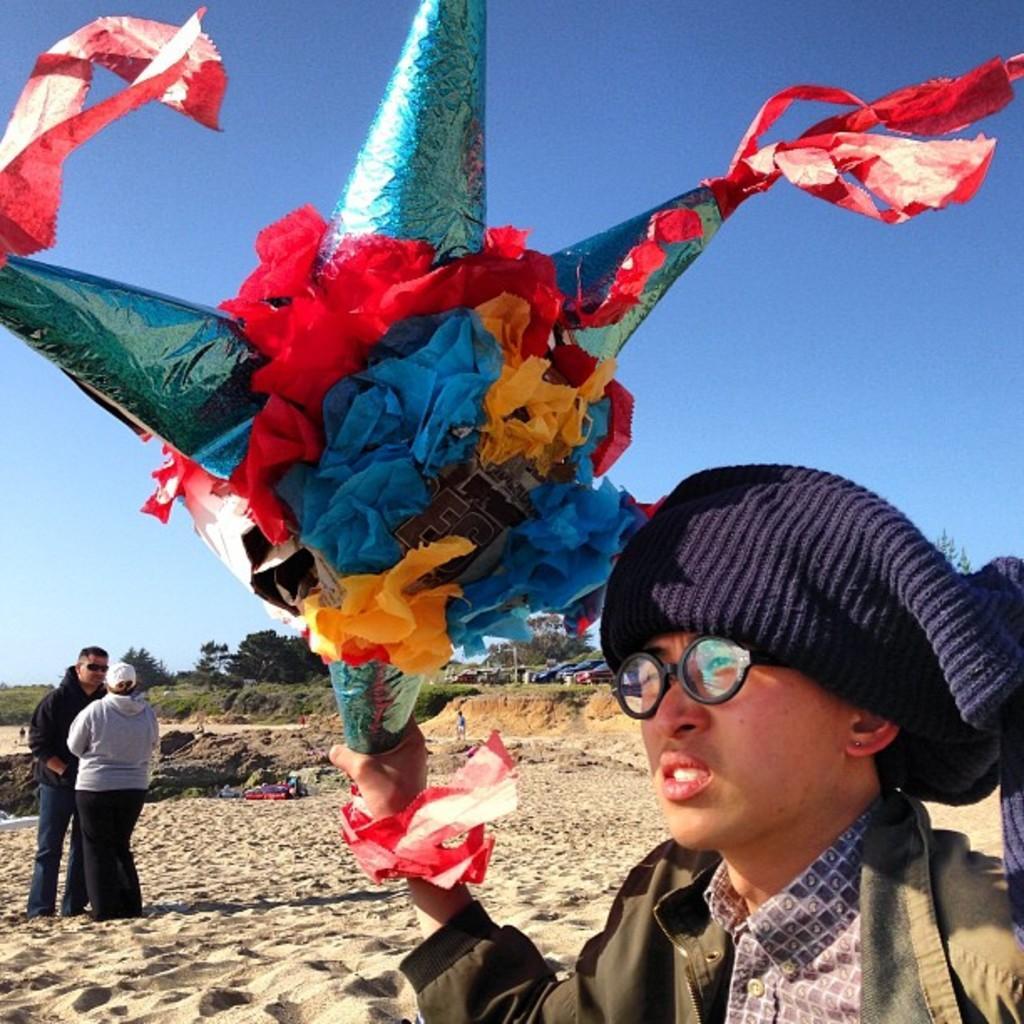Could you give a brief overview of what you see in this image? In this picture we can see a man is holding a colorful kite and on the left side of the man there are two people are standing on the path. Behind the people there are trees, sky and other things. 